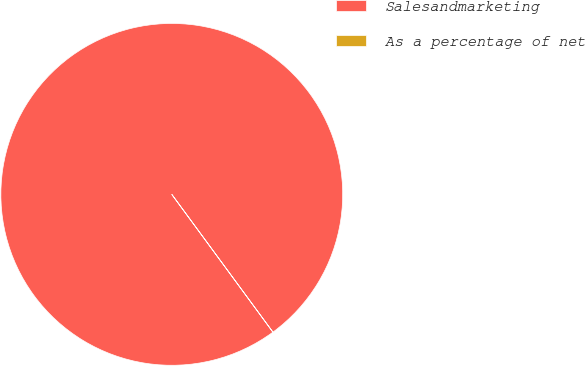Convert chart to OTSL. <chart><loc_0><loc_0><loc_500><loc_500><pie_chart><fcel>Salesandmarketing<fcel>As a percentage of net<nl><fcel>100.0%<fcel>0.0%<nl></chart> 